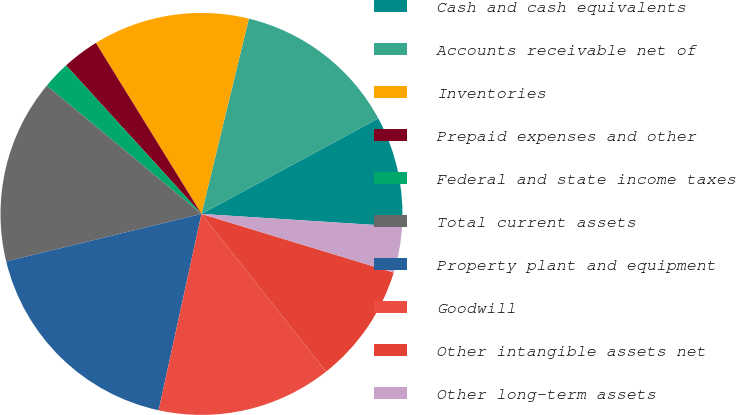<chart> <loc_0><loc_0><loc_500><loc_500><pie_chart><fcel>Cash and cash equivalents<fcel>Accounts receivable net of<fcel>Inventories<fcel>Prepaid expenses and other<fcel>Federal and state income taxes<fcel>Total current assets<fcel>Property plant and equipment<fcel>Goodwill<fcel>Other intangible assets net<fcel>Other long-term assets<nl><fcel>8.89%<fcel>13.33%<fcel>12.59%<fcel>2.96%<fcel>2.22%<fcel>14.81%<fcel>17.78%<fcel>14.07%<fcel>9.63%<fcel>3.7%<nl></chart> 